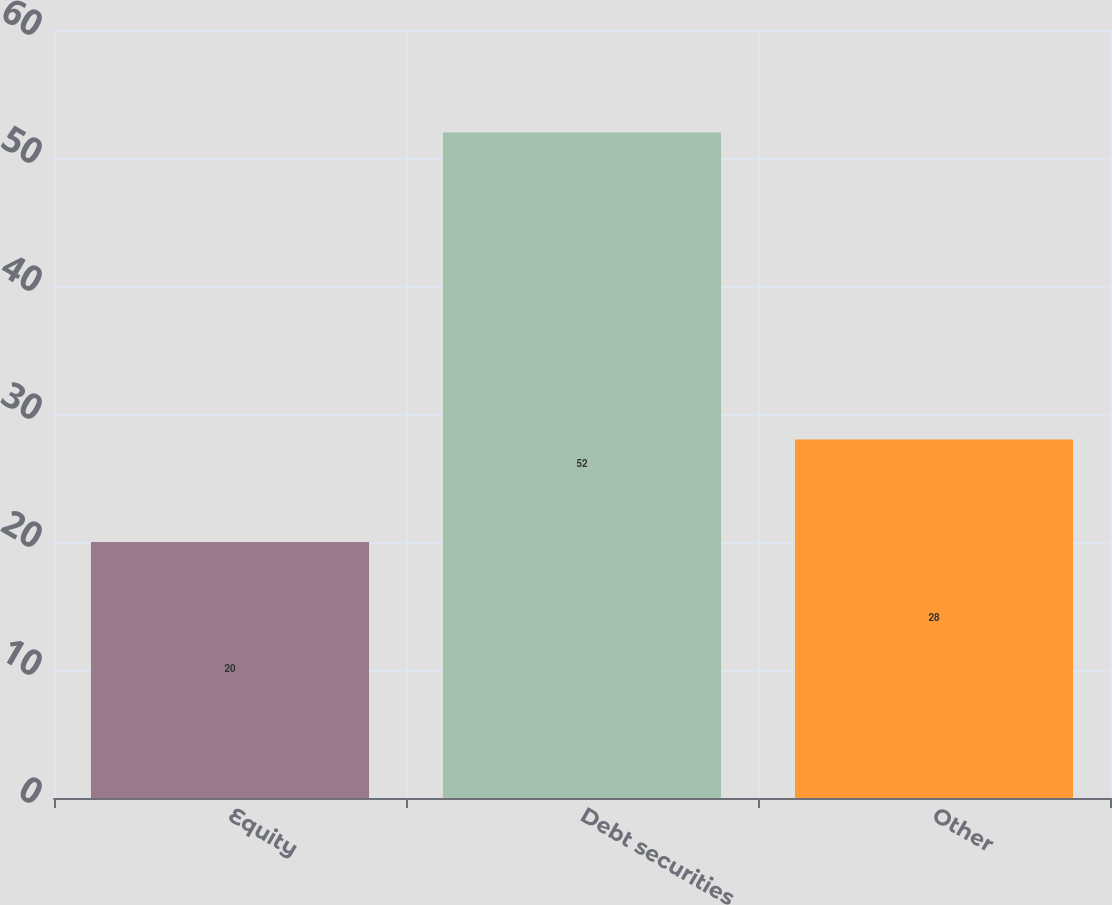Convert chart to OTSL. <chart><loc_0><loc_0><loc_500><loc_500><bar_chart><fcel>Equity<fcel>Debt securities<fcel>Other<nl><fcel>20<fcel>52<fcel>28<nl></chart> 